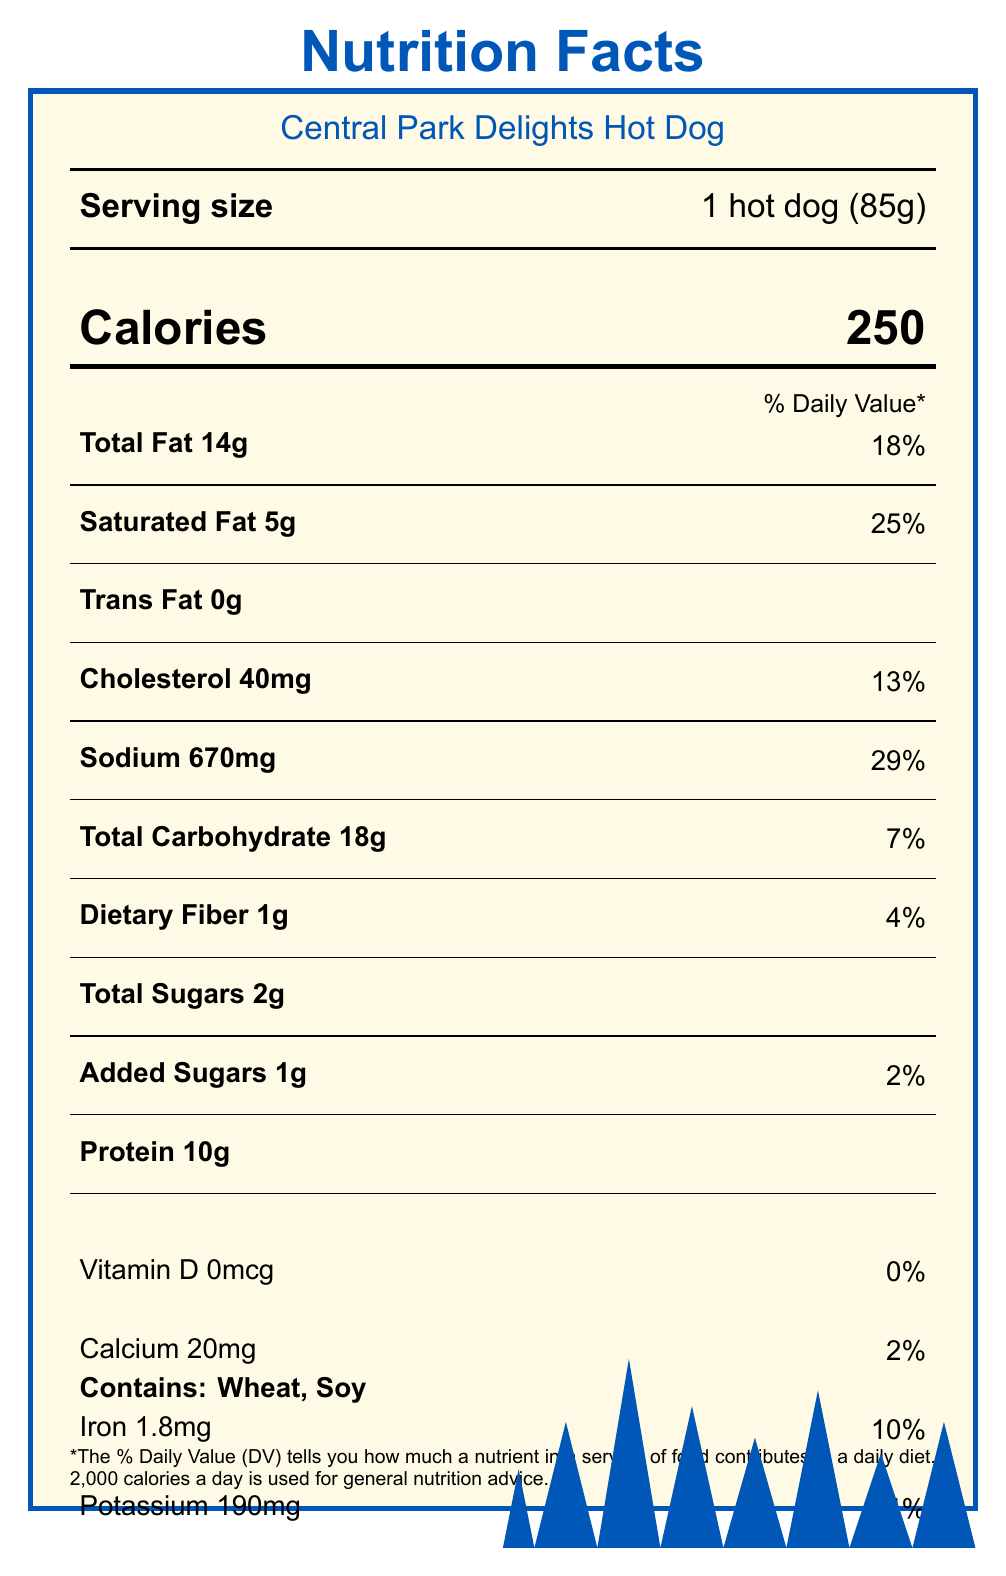what is the serving size? The serving size is listed as 1 hot dog (85g) in the serving size info section of the document.
Answer: 1 hot dog (85g) how many calories does a Central Park Delights hot dog contain? The calories count is mentioned in a large, bold font indicating that one hot dog contains 250 calories.
Answer: 250 what percentage of the daily value of saturated fat is in a Central Park Delights hot dog? The nutrition info section indicates that the saturated fat content is 5g, which is 25% of the daily value.
Answer: 25% what are the two allergens listed in the document? The document states "Contains: Wheat, Soy" in the allergen info section near the bottom.
Answer: Wheat, Soy how much sodium does one hot dog contain? The sodium content is listed as 670mg and contributes 29% to the daily value.
Answer: 670mg which of the following accompaniments are available with the hot dog? A. Avocado, Mustard B. Mustard, Ketchup, Onions C. Sauerkraut, Tomato, Lettuce The accompaniments are listed as Mustard, Ketchup, Sauerkraut, and Onions.
Answer: B how many grams of protein are in a Central Park Delights hot dog? A. 5g B. 10g C. 18g D. 25g The protein content in the hot dog is listed as 10g.
Answer: B what is the location of the vendor? A. Times Square B. Near Bethesda Fountain, Central Park C. Statue of Liberty The document specifies that the vendor's location is near Bethesda Fountain in Central Park.
Answer: B is this hot dog children-friendly according to the document? The note "Perfect size for children, easy to hold and eat while exploring the park" indicates that it is children-friendly.
Answer: Yes can the exact price of the hot dog be found in the document? The document provides nutritional information but does not mention the price.
Answer: Not enough information summarize the main idea of the document. The document serves as a nutrition facts label for a hot dog sold by Central Park Delights, detailing various nutritional values, allergens, ingredients, and additional contextual information to help consumers understand its nutritional impact and options for healthier alternatives.
Answer: The document provides nutritional information about a hot dog from Central Park Delights, including serving size, calorie count, nutrient content, allergen information, and additional notes on its cultural significance and children-friendliness. 